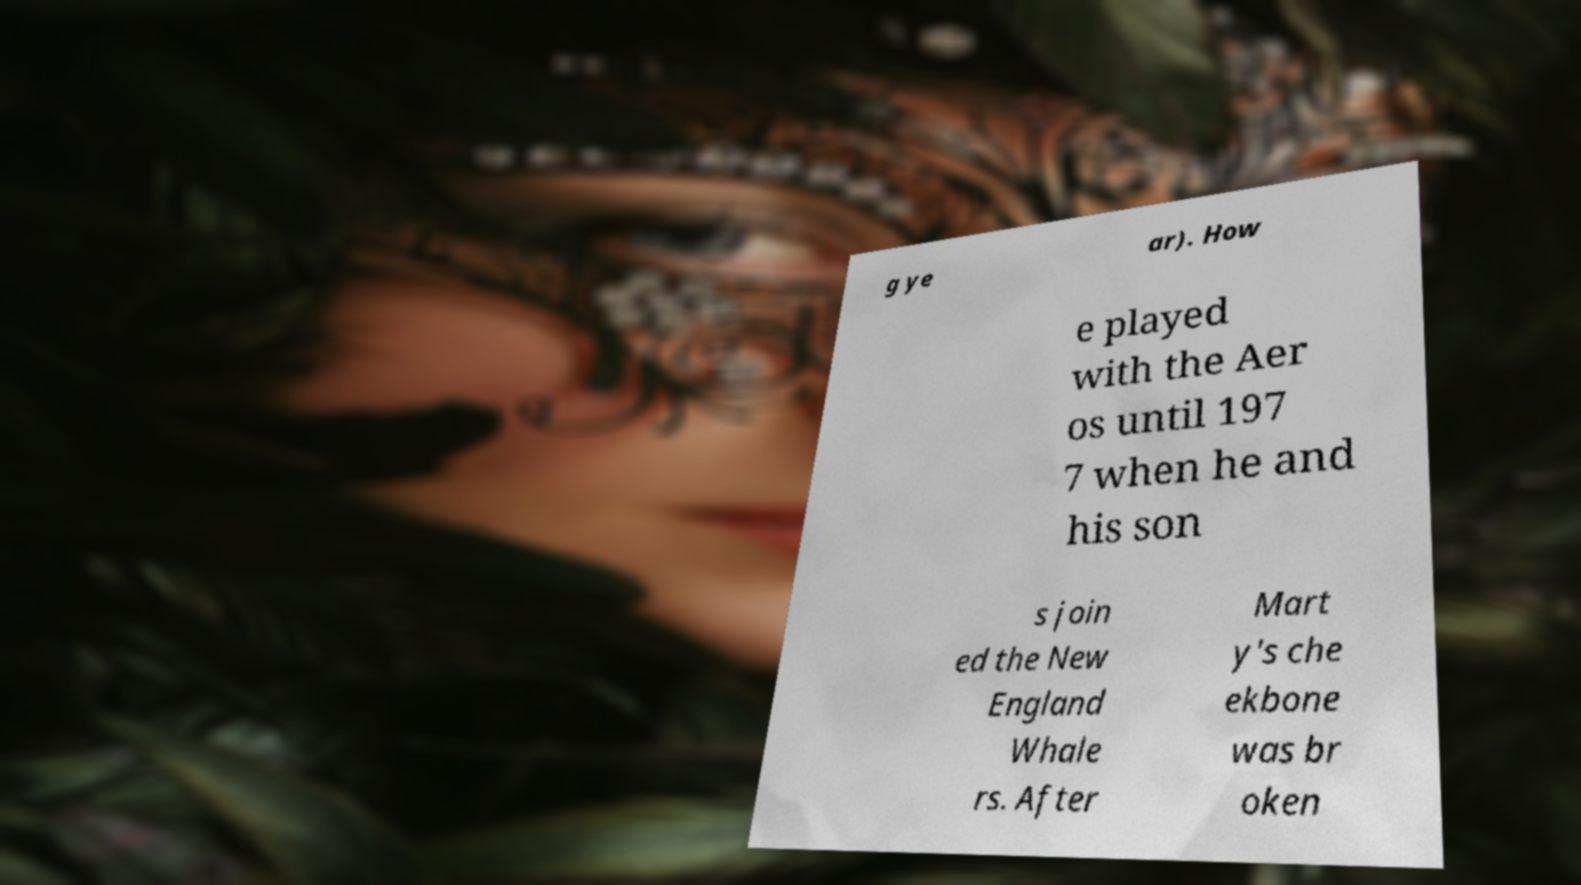Can you describe any symbolism you interpret from the juxtaposition of the visible text and the partially visible face in the background? The partial visibility of the person's face behind the document might symbolize the idea of obscured identity or half-told stories. The document itself, covering part of the face, suggests that our identity or perhaps our past actions and experiences, symbolized by the text, partly define yet also conceal who we are. It speaks to the complex interaction between a person's history and how they are perceived or choose to reveal themselves to the world. 